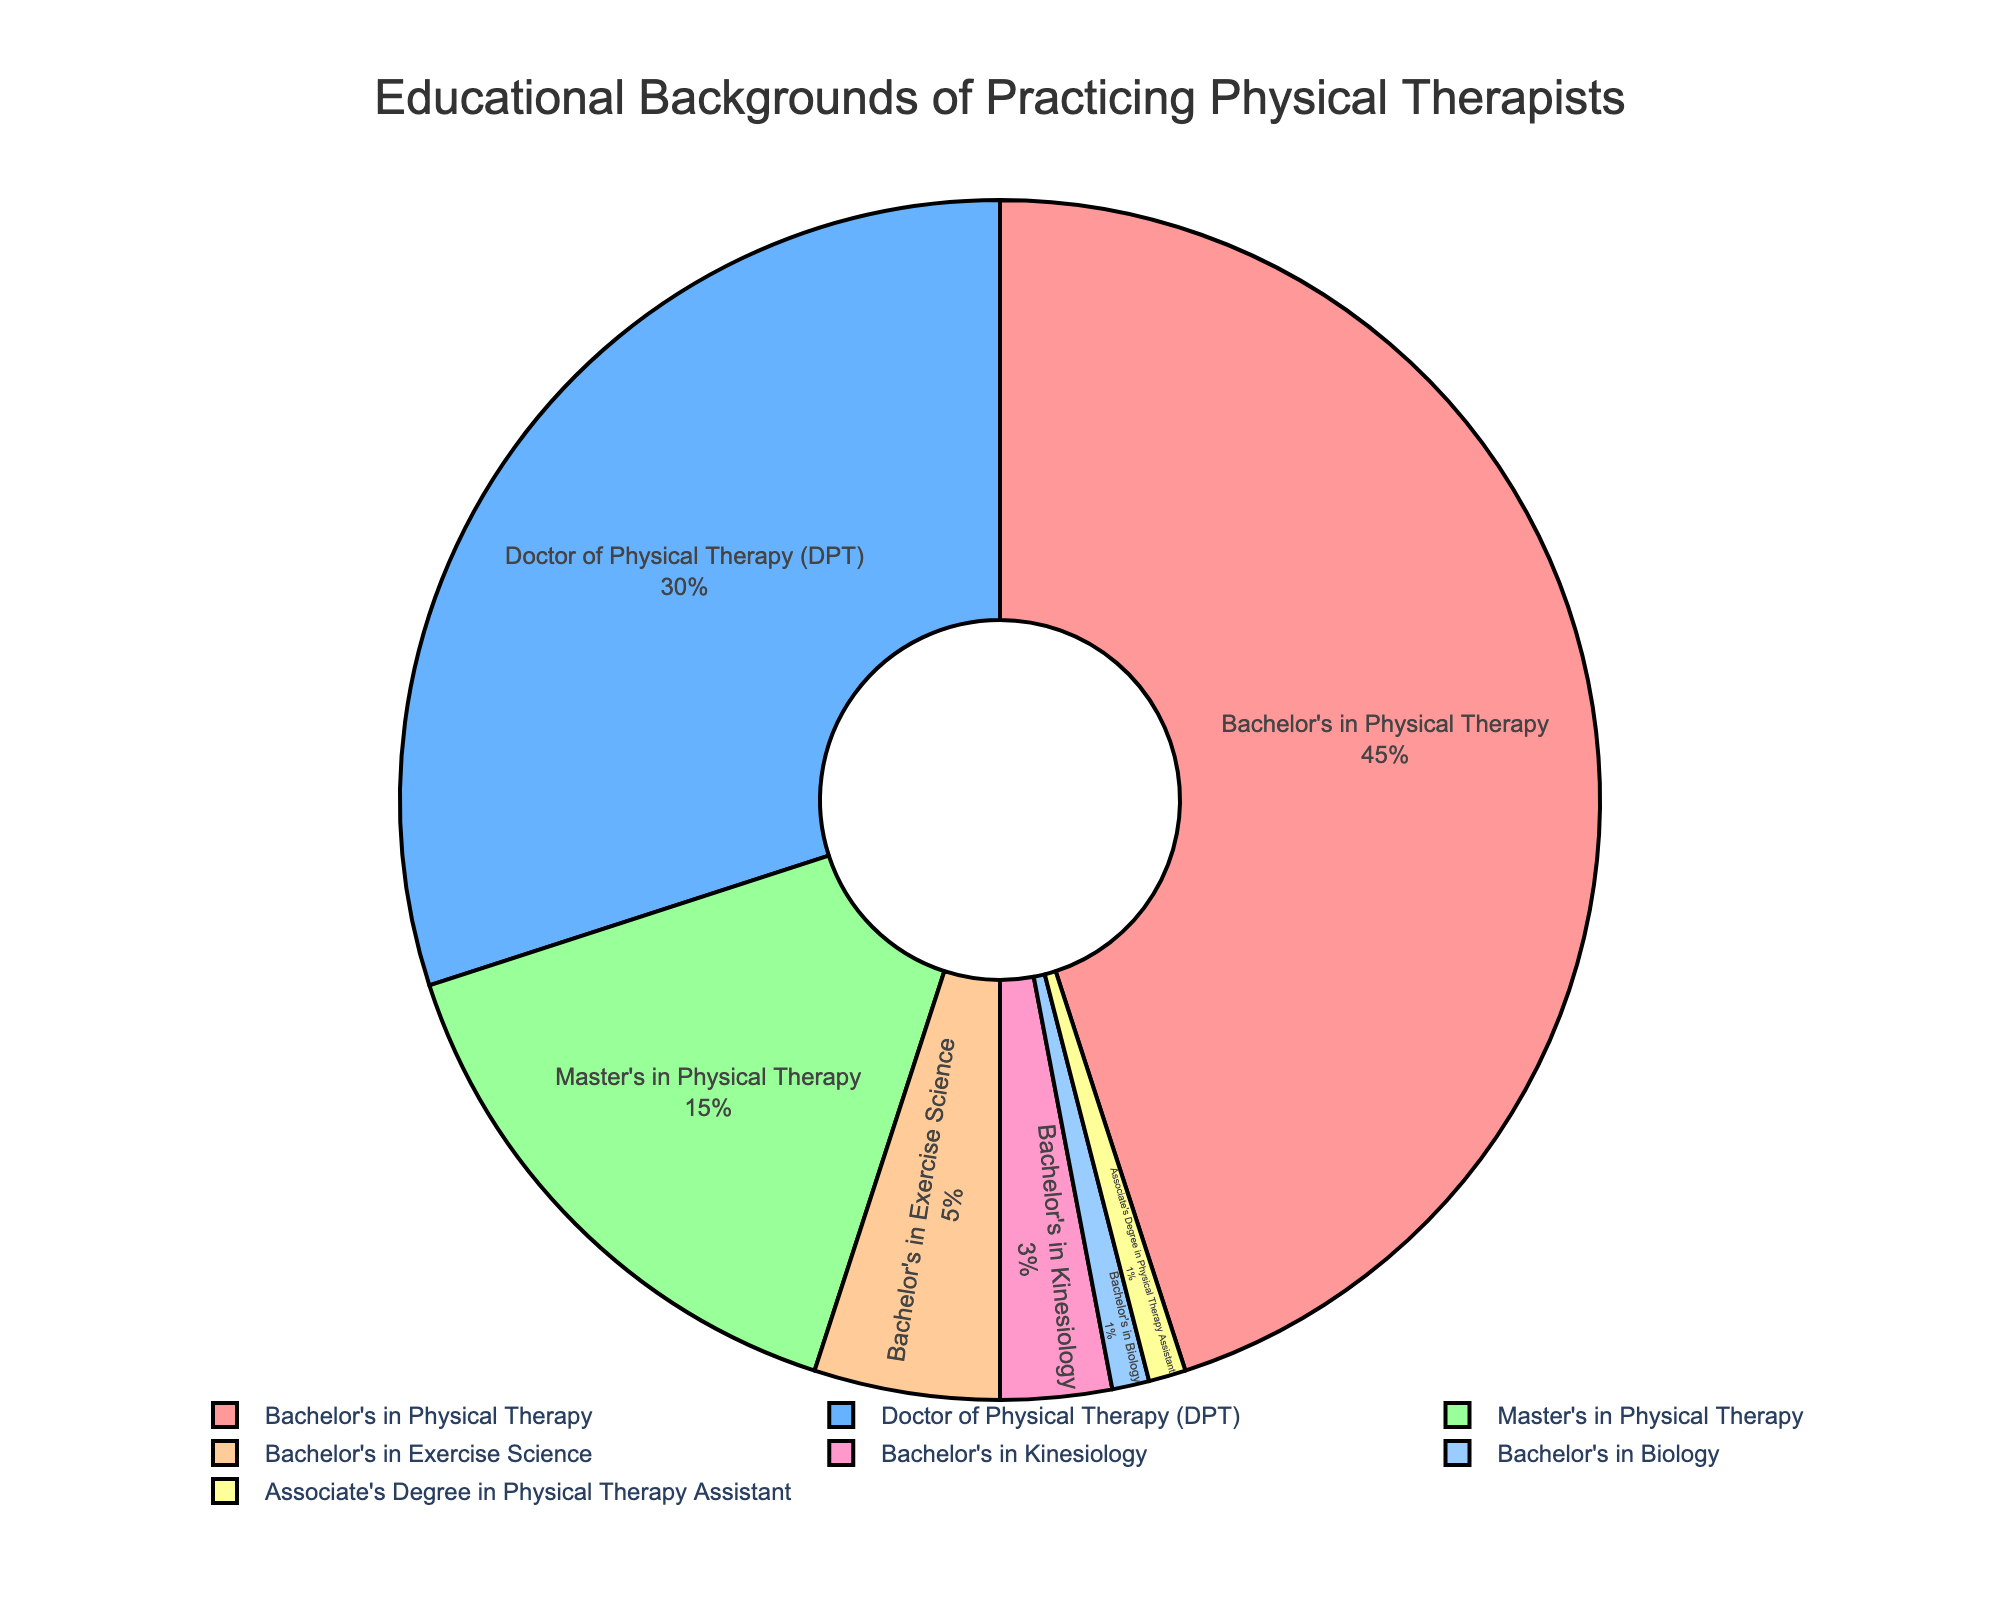What percentage of practicing physical therapists have a Bachelor's in Physical Therapy? According to the pie chart, 45% of practicing physical therapists have a Bachelor's in Physical Therapy.
Answer: 45% What educational background has the second highest percentage among practicing physical therapists? The pie chart shows that the Doctor of Physical Therapy (DPT) has the second highest percentage, at 30%.
Answer: Doctor of Physical Therapy (DPT) What is the sum of percentages for Master's in Physical Therapy, Bachelor's in Exercise Science, and Bachelor's in Kinesiology? The sum of the percentages is 15% (Master's in Physical Therapy) + 5% (Bachelor's in Exercise Science) + 3% (Bachelor's in Kinesiology) = 23%.
Answer: 23% How many educational backgrounds have a percentage of 1% among practicing physical therapists? The pie chart shows that there are two educational backgrounds with a percentage of 1% each: Bachelor's in Biology and Associate's Degree in Physical Therapy Assistant.
Answer: 2 Which educational background is represented by the primary color red? The pie chart uses a specific color scheme, and the segment filled with red represents Bachelor's in Physical Therapy.
Answer: Bachelor's in Physical Therapy Which has a lower percentage: Bachelor's in Kinesiology or Bachelor's in Biology? The pie chart indicates that Bachelor's in Biology has a lower percentage (1%) compared to Bachelor's in Kinesiology (3%).
Answer: Bachelor's in Biology What is the difference in percentage between Doctor of Physical Therapy and Master's in Physical Therapy? The percentage for Doctor of Physical Therapy is 30%, while for Master's in Physical Therapy it's 15%. The difference is 30% - 15% = 15%.
Answer: 15% What is the combined percentage of the two least common educational backgrounds among practicing physical therapists? The least common backgrounds are Bachelor's in Biology (1%) and Associate's Degree in Physical Therapy Assistant (1%). Combined, they make up 1% + 1% = 2%.
Answer: 2% Which educational background appears just below Bachelor's in Physical Therapy in percentage ranking? According to the pie chart, Doctor of Physical Therapy (DPT) at 30% is just below Bachelor's in Physical Therapy, which is at 45%.
Answer: Doctor of Physical Therapy (DPT) What is the difference in percentage between the educational background with the highest percentage and the educational background with the lowest percentage? The highest percentage is Bachelor's in Physical Therapy at 45%, and the lowest percentage is Bachelor's in Biology and Associate's Degree in Physical Therapy Assistant, both at 1%. The difference is 45% - 1% = 44%.
Answer: 44% 